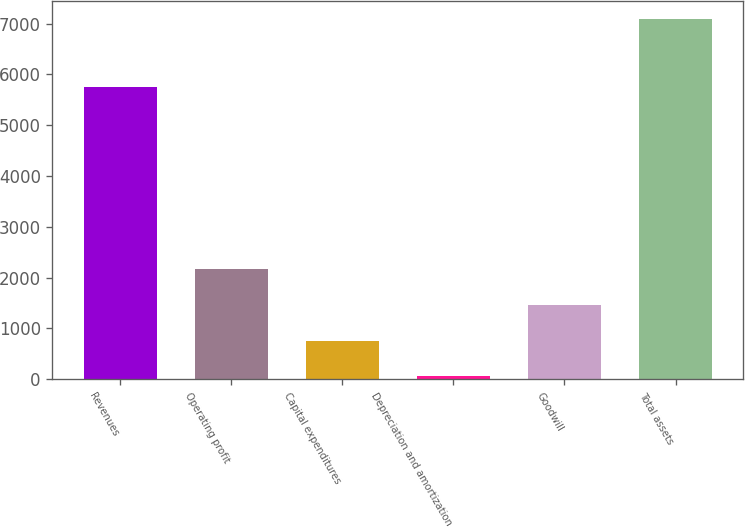Convert chart to OTSL. <chart><loc_0><loc_0><loc_500><loc_500><bar_chart><fcel>Revenues<fcel>Operating profit<fcel>Capital expenditures<fcel>Depreciation and amortization<fcel>Goodwill<fcel>Total assets<nl><fcel>5744.7<fcel>2166.63<fcel>758.01<fcel>53.7<fcel>1462.32<fcel>7096.8<nl></chart> 